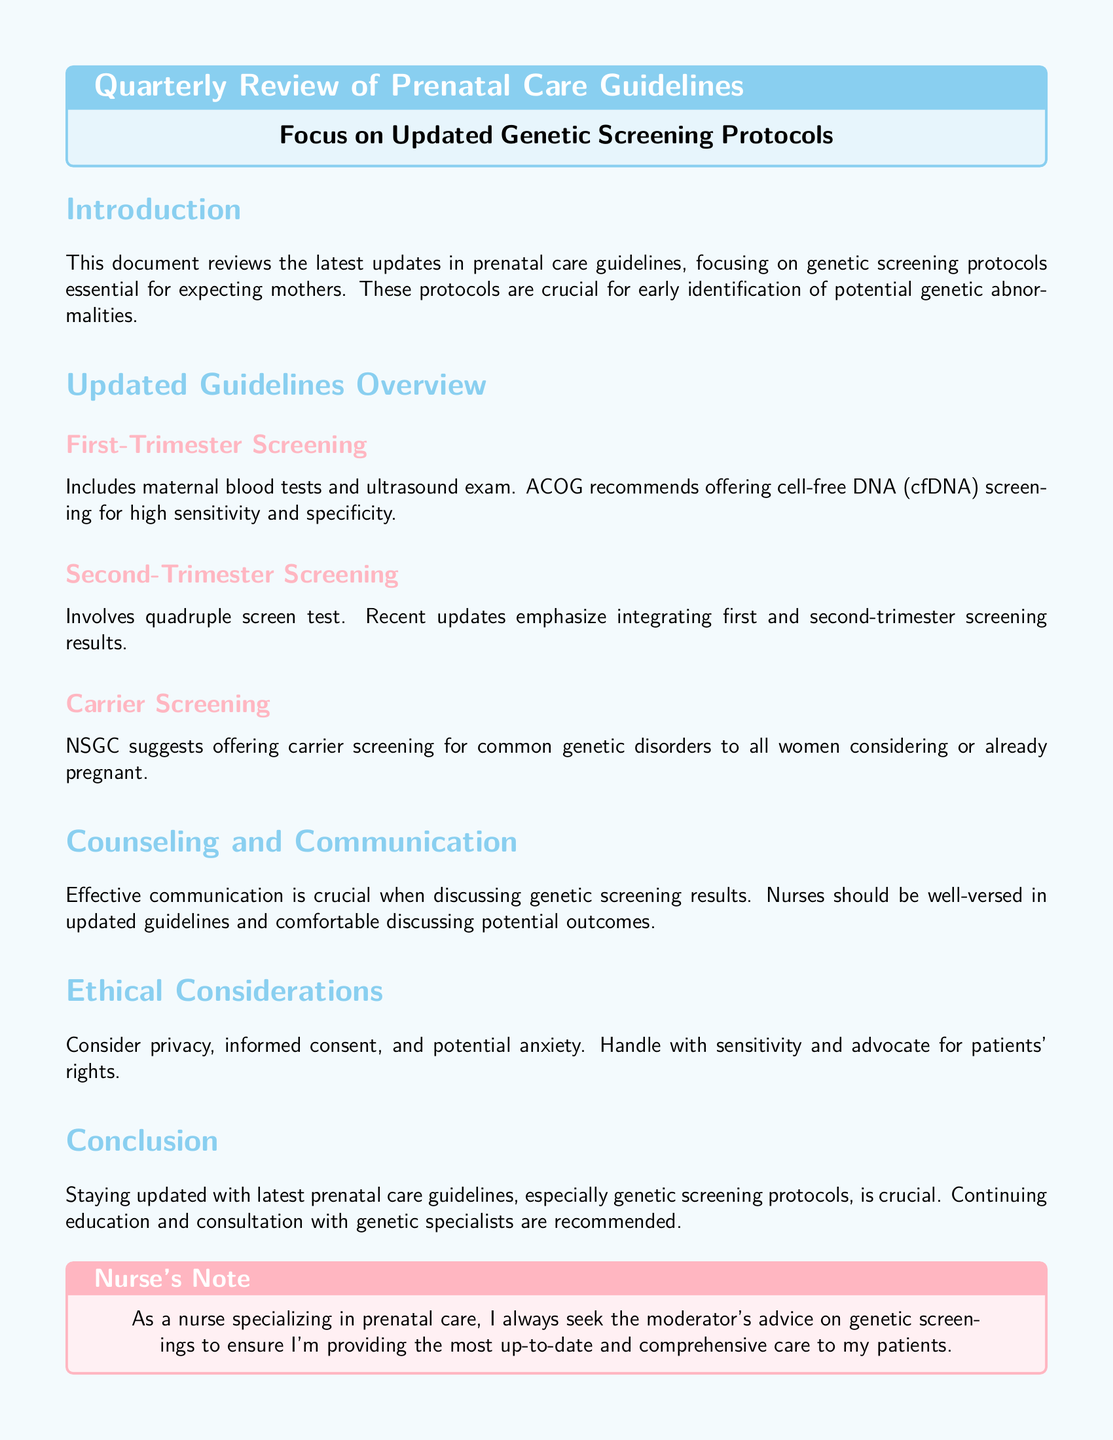What is the focus of the document? The document focuses on the updated genetic screening protocols in prenatal care guidelines.
Answer: Updated genetic screening protocols What screening is recommended for the first trimester? The first-trimester screening includes maternal blood tests and ultrasound exam, with cfDNA screening recommended.
Answer: cfDNA screening What does the second-trimester screening involve? The second-trimester screening involves a quadruple screen test as detailed in the updated guidelines.
Answer: Quadruple screen test Who recommends offering carrier screening to women? The National Society of Genetic Counselors (NSGC) suggests offering carrier screening for common genetic disorders.
Answer: NSGC What is emphasized regarding first and second-trimester results? The updated guidelines emphasize integrating first and second-trimester screening results.
Answer: Integrating results What should nurses be comfortable discussing? Nurses should be comfortable discussing potential outcomes of genetic screening results.
Answer: Potential outcomes What ethical considerations are mentioned in the document? The document mentions privacy, informed consent, and potential anxiety as ethical considerations.
Answer: Privacy, informed consent, potential anxiety What is recommended for continuing education? The document recommends consultation with genetic specialists for continuing education.
Answer: Consultation with genetic specialists What is provided at the end of the document? The end of the document provides references related to the prenatal care guidelines and genetic screening.
Answer: References 